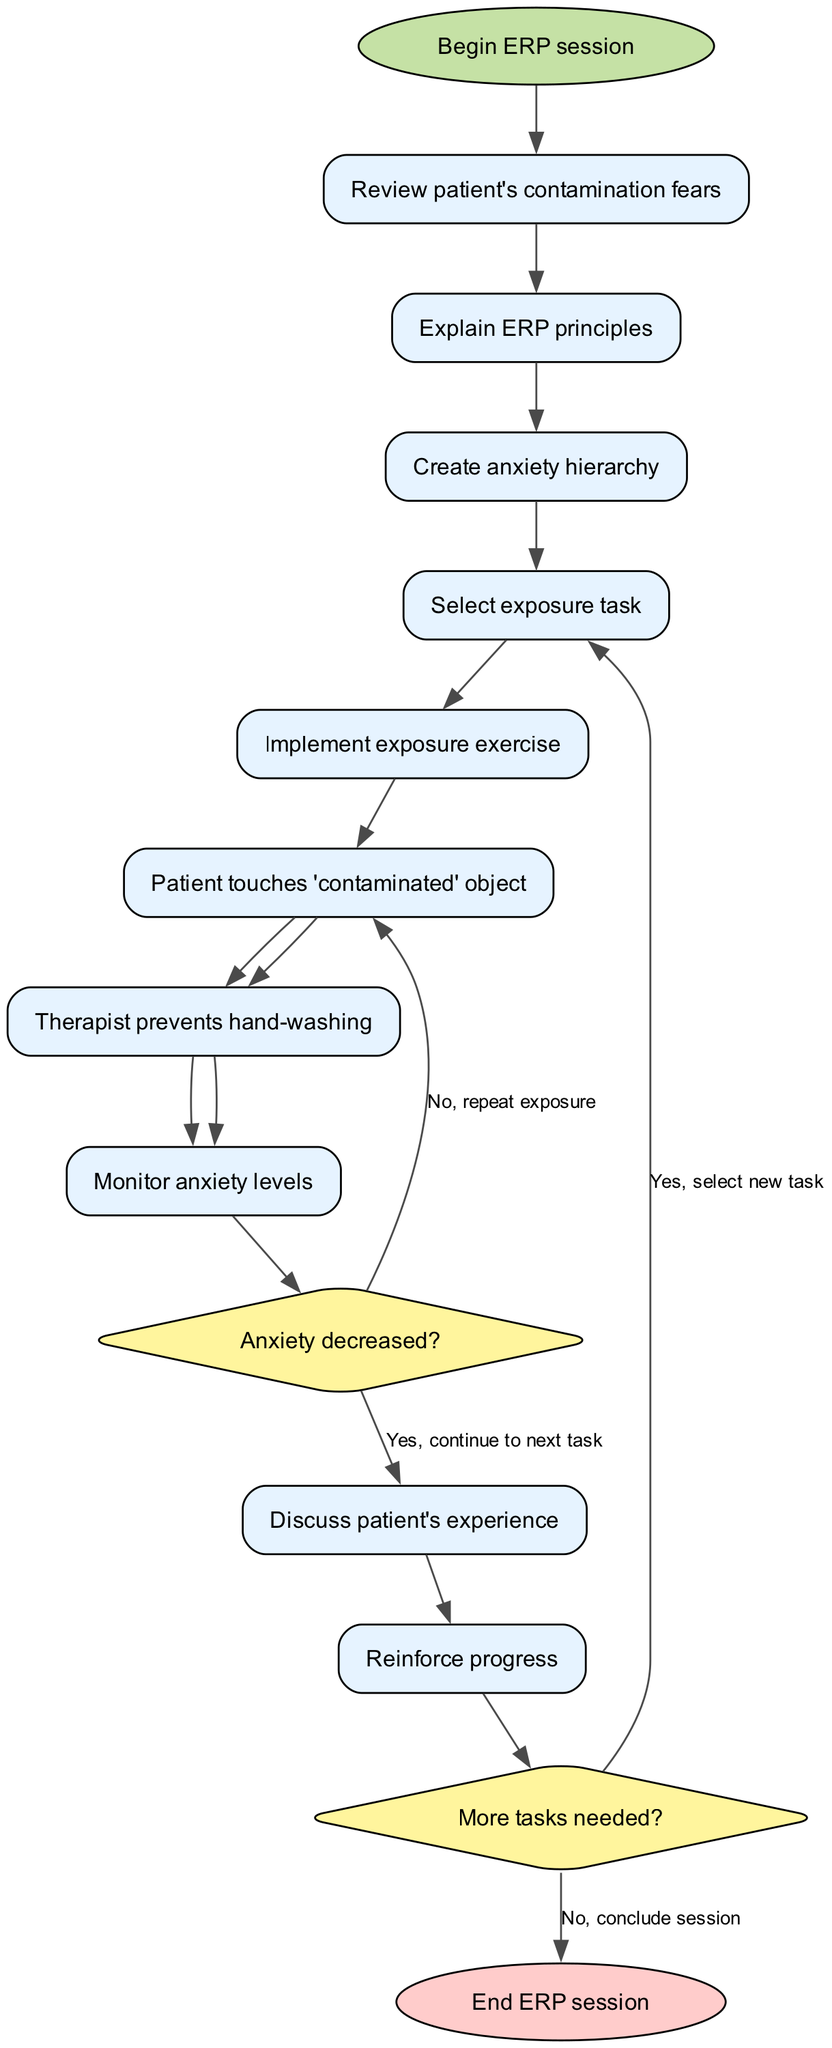What is the first activity in the ERP session? The diagram starts from the "Begin ERP session" node, leading to the first activity node which is "Review patient's contamination fears."
Answer: Review patient's contamination fears How many activities are there in total? Counting all the activities listed in the diagram, there are a total of 10 activities from "Review patient's contamination fears" to "Reinforce progress."
Answer: 10 What is the last decision node in the diagram? The last decision node present in the diagram is "More tasks needed?" which follows after the "Reinforce progress" activity.
Answer: More tasks needed? If the patient's anxiety does not decrease after touching the contaminated object, what is the next step? The flow indicates that if the patient's anxiety does not decrease (answering "No" to the decision), the action taken is to "repeat exposure," leading back to the appropriate activity.
Answer: Repeat exposure How many decision nodes are present in the diagram? The diagram includes two decision nodes, one labeled "Anxiety decreased?" and the other labeled "More tasks needed?"
Answer: 2 What happens if the patient's anxiety decreases after the exposure exercise? If the patient's anxiety decreases, the flow indicates to continue to the next task, which allows the session to progress based on the success of the exposure.
Answer: Continue to next task What is the outcome if no more tasks are needed? If the answer to "More tasks needed?" is "No," the flow ends with the node labeled "End ERP session," concluding the therapy session.
Answer: End ERP session Which activity directly follows "Monitor anxiety levels"? After "Monitor anxiety levels," the next activity specified in the diagram is "Discuss patient's experience."
Answer: Discuss patient's experience What color represents the decision nodes in the diagram? The decision nodes in the diagram are colored with a fill color of '#FFF59D', indicating their unique design for decision-making processes.
Answer: Yellow 